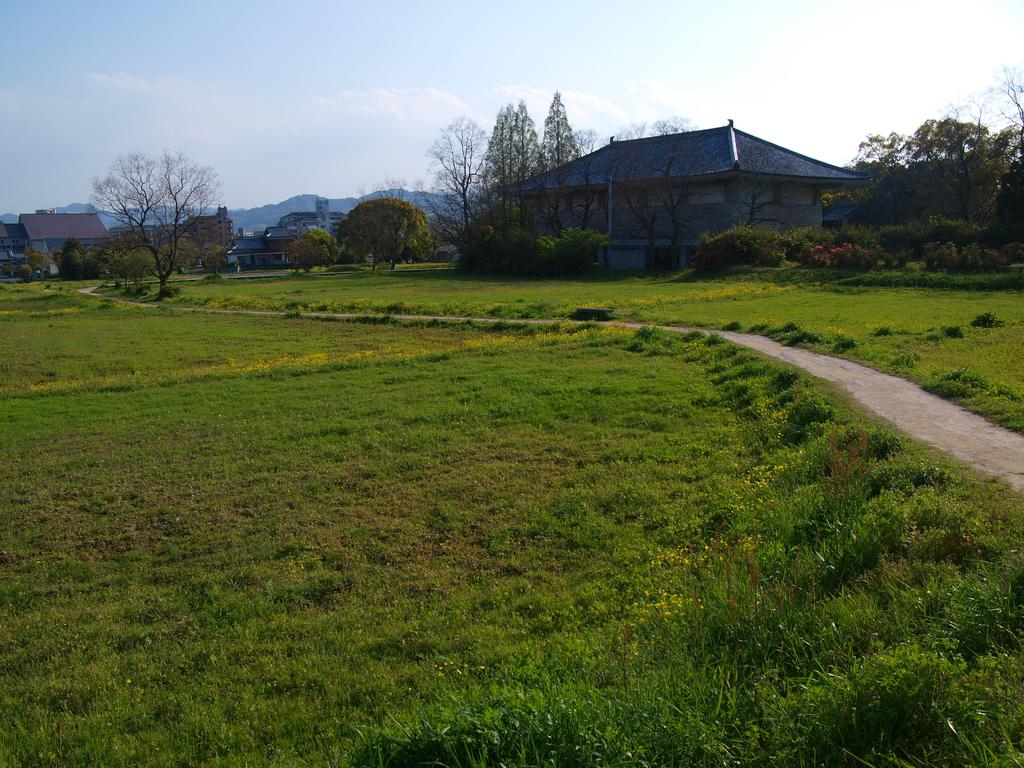What type of surface is visible in the image? There is a ground in the image. What can be found on the ground in the image? There are trees and a house on the ground. What is visible at the top of the image? The sky is visible at the top of the image. What type of geographical feature is present in the image? There is a hill in the image, and another hill is visible on the left side of the image. Where is the pen located in the image? There is no pen present in the image. What type of toys can be seen on the hill in the image? There are no toys present in the image. 